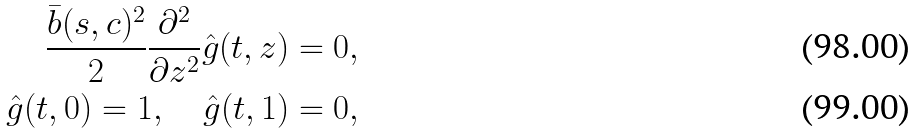Convert formula to latex. <formula><loc_0><loc_0><loc_500><loc_500>\frac { \bar { b } ( s , c ) ^ { 2 } } { 2 } \frac { \partial ^ { 2 } } { \partial z ^ { 2 } } \hat { g } ( t , z ) = 0 , \\ \hat { g } ( t , 0 ) = 1 , \quad \hat { g } ( t , 1 ) = 0 ,</formula> 